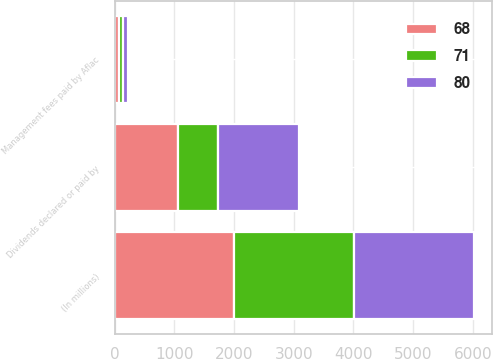Convert chart. <chart><loc_0><loc_0><loc_500><loc_500><stacked_bar_chart><ecel><fcel>(In millions)<fcel>Dividends declared or paid by<fcel>Management fees paid by Aflac<nl><fcel>68<fcel>2008<fcel>1062<fcel>71<nl><fcel>80<fcel>2007<fcel>1362<fcel>80<nl><fcel>71<fcel>2006<fcel>665<fcel>68<nl></chart> 